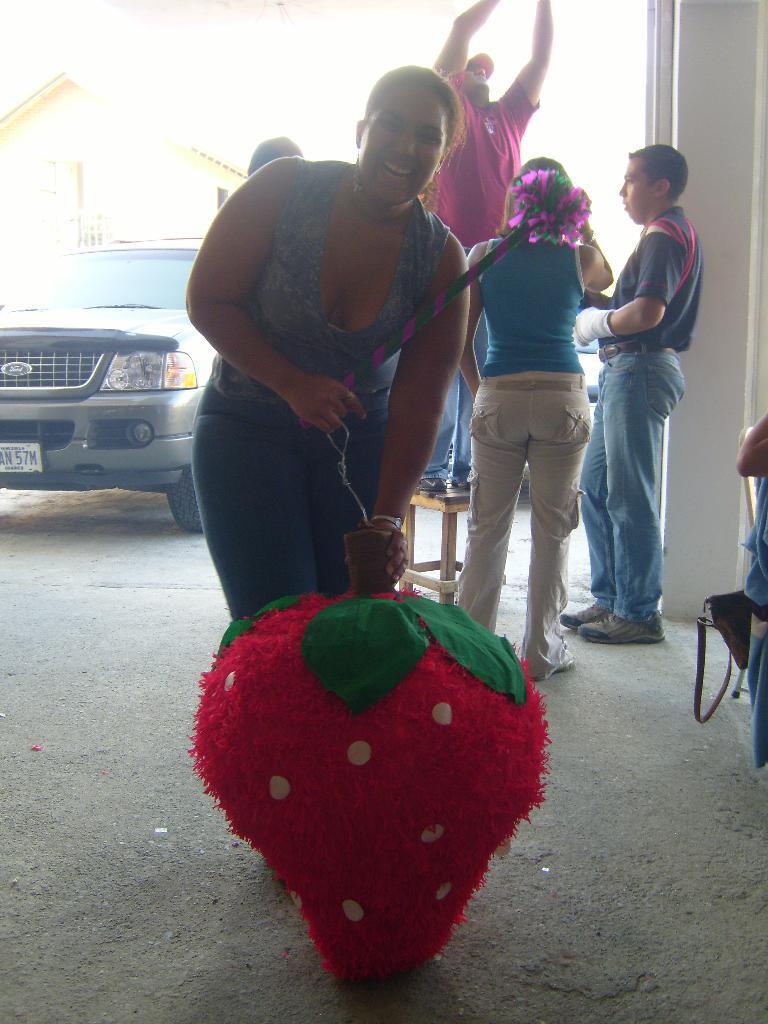Please provide a concise description of this image. In the center of the image we can see a woman holding a stick and a toy. On the backside we can see a group of people standing. In that a man is standing on a stool. We can also see a house and a car parked aside. 